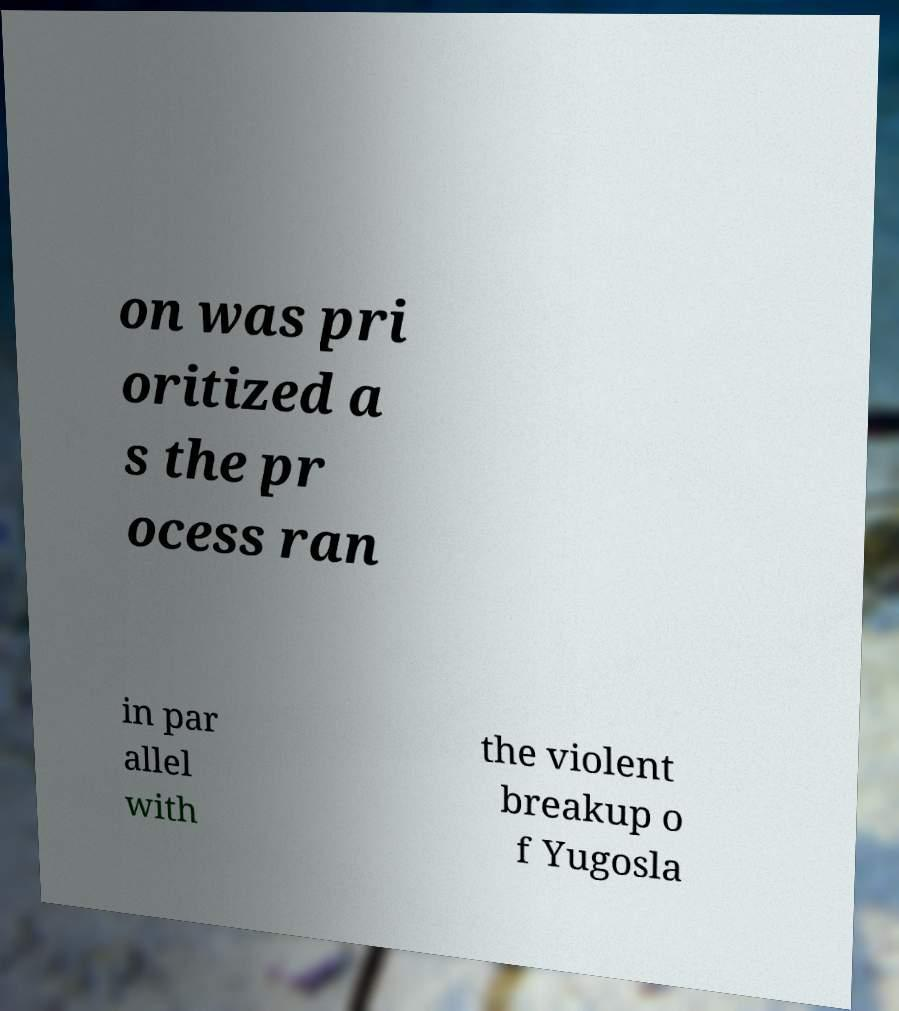I need the written content from this picture converted into text. Can you do that? on was pri oritized a s the pr ocess ran in par allel with the violent breakup o f Yugosla 